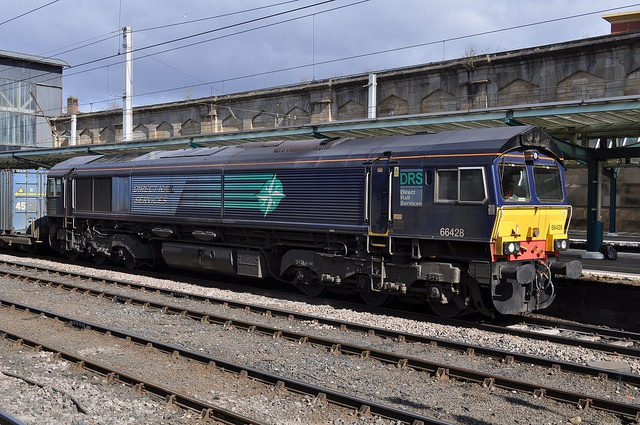Describe the objects in this image and their specific colors. I can see a train in lavender, black, gray, and navy tones in this image. 